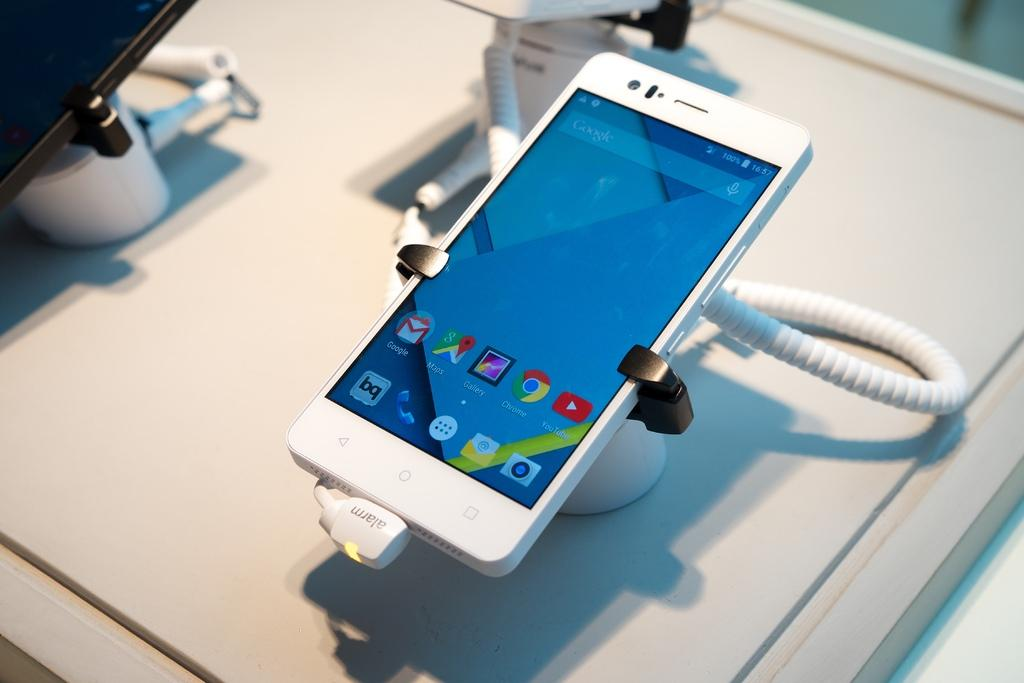<image>
Create a compact narrative representing the image presented. the word Chrome is on the front of the phone 